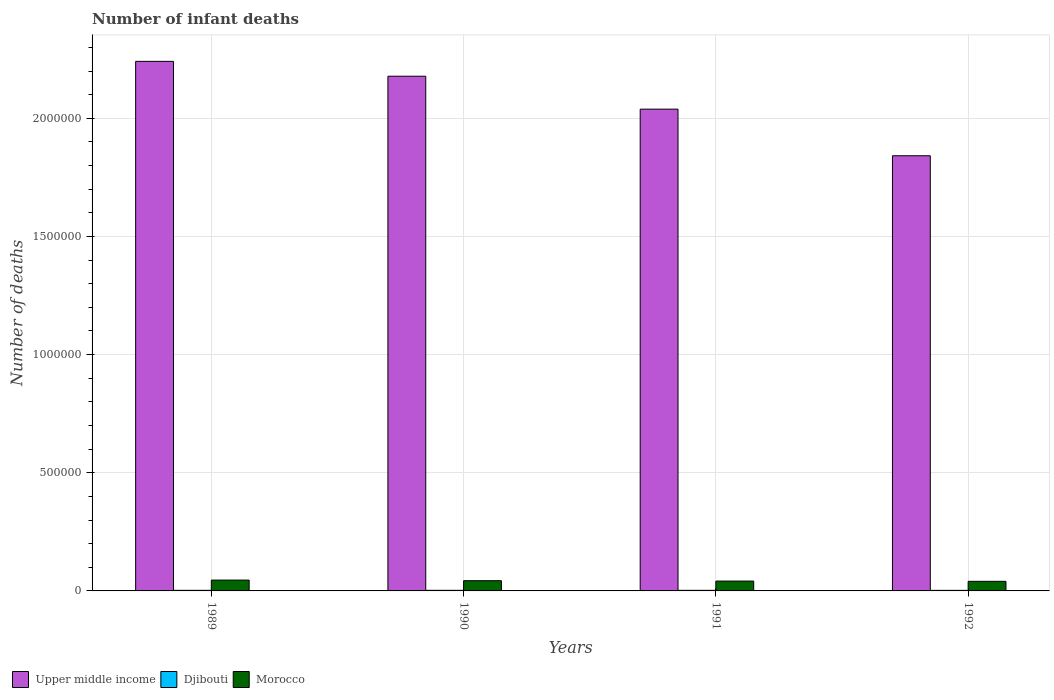Are the number of bars per tick equal to the number of legend labels?
Make the answer very short. Yes. What is the label of the 1st group of bars from the left?
Offer a terse response. 1989. What is the number of infant deaths in Morocco in 1990?
Give a very brief answer. 4.33e+04. Across all years, what is the maximum number of infant deaths in Djibouti?
Make the answer very short. 2531. Across all years, what is the minimum number of infant deaths in Upper middle income?
Make the answer very short. 1.84e+06. In which year was the number of infant deaths in Djibouti maximum?
Offer a terse response. 1990. In which year was the number of infant deaths in Upper middle income minimum?
Your answer should be very brief. 1992. What is the total number of infant deaths in Morocco in the graph?
Provide a short and direct response. 1.71e+05. What is the difference between the number of infant deaths in Djibouti in 1991 and that in 1992?
Provide a succinct answer. 133. What is the difference between the number of infant deaths in Morocco in 1991 and the number of infant deaths in Djibouti in 1990?
Offer a terse response. 3.91e+04. What is the average number of infant deaths in Morocco per year?
Make the answer very short. 4.29e+04. In the year 1990, what is the difference between the number of infant deaths in Djibouti and number of infant deaths in Upper middle income?
Your answer should be compact. -2.18e+06. In how many years, is the number of infant deaths in Morocco greater than 1800000?
Offer a terse response. 0. What is the ratio of the number of infant deaths in Upper middle income in 1990 to that in 1991?
Offer a terse response. 1.07. Is the difference between the number of infant deaths in Djibouti in 1989 and 1991 greater than the difference between the number of infant deaths in Upper middle income in 1989 and 1991?
Provide a succinct answer. No. What is the difference between the highest and the second highest number of infant deaths in Djibouti?
Provide a succinct answer. 23. What is the difference between the highest and the lowest number of infant deaths in Upper middle income?
Provide a short and direct response. 3.99e+05. Is the sum of the number of infant deaths in Upper middle income in 1989 and 1990 greater than the maximum number of infant deaths in Djibouti across all years?
Give a very brief answer. Yes. What does the 2nd bar from the left in 1992 represents?
Your response must be concise. Djibouti. What does the 3rd bar from the right in 1992 represents?
Your answer should be compact. Upper middle income. Is it the case that in every year, the sum of the number of infant deaths in Djibouti and number of infant deaths in Morocco is greater than the number of infant deaths in Upper middle income?
Provide a short and direct response. No. Are all the bars in the graph horizontal?
Offer a very short reply. No. How many years are there in the graph?
Provide a succinct answer. 4. Does the graph contain any zero values?
Your response must be concise. No. Does the graph contain grids?
Offer a terse response. Yes. Where does the legend appear in the graph?
Offer a terse response. Bottom left. How are the legend labels stacked?
Offer a terse response. Horizontal. What is the title of the graph?
Your response must be concise. Number of infant deaths. Does "Congo (Democratic)" appear as one of the legend labels in the graph?
Make the answer very short. No. What is the label or title of the Y-axis?
Ensure brevity in your answer.  Number of deaths. What is the Number of deaths of Upper middle income in 1989?
Your answer should be very brief. 2.24e+06. What is the Number of deaths in Djibouti in 1989?
Offer a very short reply. 2457. What is the Number of deaths in Morocco in 1989?
Offer a very short reply. 4.59e+04. What is the Number of deaths in Upper middle income in 1990?
Provide a succinct answer. 2.18e+06. What is the Number of deaths of Djibouti in 1990?
Provide a succinct answer. 2531. What is the Number of deaths of Morocco in 1990?
Keep it short and to the point. 4.33e+04. What is the Number of deaths in Upper middle income in 1991?
Offer a very short reply. 2.04e+06. What is the Number of deaths in Djibouti in 1991?
Ensure brevity in your answer.  2508. What is the Number of deaths of Morocco in 1991?
Your answer should be compact. 4.17e+04. What is the Number of deaths in Upper middle income in 1992?
Make the answer very short. 1.84e+06. What is the Number of deaths of Djibouti in 1992?
Your answer should be very brief. 2375. What is the Number of deaths of Morocco in 1992?
Your response must be concise. 4.06e+04. Across all years, what is the maximum Number of deaths of Upper middle income?
Provide a short and direct response. 2.24e+06. Across all years, what is the maximum Number of deaths of Djibouti?
Your answer should be very brief. 2531. Across all years, what is the maximum Number of deaths of Morocco?
Your answer should be compact. 4.59e+04. Across all years, what is the minimum Number of deaths of Upper middle income?
Your response must be concise. 1.84e+06. Across all years, what is the minimum Number of deaths in Djibouti?
Offer a terse response. 2375. Across all years, what is the minimum Number of deaths in Morocco?
Give a very brief answer. 4.06e+04. What is the total Number of deaths in Upper middle income in the graph?
Offer a very short reply. 8.30e+06. What is the total Number of deaths in Djibouti in the graph?
Provide a short and direct response. 9871. What is the total Number of deaths in Morocco in the graph?
Your answer should be compact. 1.71e+05. What is the difference between the Number of deaths in Upper middle income in 1989 and that in 1990?
Make the answer very short. 6.29e+04. What is the difference between the Number of deaths in Djibouti in 1989 and that in 1990?
Your answer should be compact. -74. What is the difference between the Number of deaths of Morocco in 1989 and that in 1990?
Offer a terse response. 2608. What is the difference between the Number of deaths of Upper middle income in 1989 and that in 1991?
Ensure brevity in your answer.  2.02e+05. What is the difference between the Number of deaths of Djibouti in 1989 and that in 1991?
Offer a very short reply. -51. What is the difference between the Number of deaths in Morocco in 1989 and that in 1991?
Provide a short and direct response. 4208. What is the difference between the Number of deaths in Upper middle income in 1989 and that in 1992?
Your answer should be very brief. 3.99e+05. What is the difference between the Number of deaths in Morocco in 1989 and that in 1992?
Your answer should be compact. 5280. What is the difference between the Number of deaths of Upper middle income in 1990 and that in 1991?
Make the answer very short. 1.39e+05. What is the difference between the Number of deaths of Djibouti in 1990 and that in 1991?
Provide a short and direct response. 23. What is the difference between the Number of deaths in Morocco in 1990 and that in 1991?
Make the answer very short. 1600. What is the difference between the Number of deaths of Upper middle income in 1990 and that in 1992?
Your answer should be compact. 3.37e+05. What is the difference between the Number of deaths in Djibouti in 1990 and that in 1992?
Give a very brief answer. 156. What is the difference between the Number of deaths of Morocco in 1990 and that in 1992?
Ensure brevity in your answer.  2672. What is the difference between the Number of deaths in Upper middle income in 1991 and that in 1992?
Ensure brevity in your answer.  1.97e+05. What is the difference between the Number of deaths in Djibouti in 1991 and that in 1992?
Offer a very short reply. 133. What is the difference between the Number of deaths in Morocco in 1991 and that in 1992?
Provide a short and direct response. 1072. What is the difference between the Number of deaths in Upper middle income in 1989 and the Number of deaths in Djibouti in 1990?
Provide a short and direct response. 2.24e+06. What is the difference between the Number of deaths in Upper middle income in 1989 and the Number of deaths in Morocco in 1990?
Offer a terse response. 2.20e+06. What is the difference between the Number of deaths in Djibouti in 1989 and the Number of deaths in Morocco in 1990?
Your answer should be compact. -4.08e+04. What is the difference between the Number of deaths in Upper middle income in 1989 and the Number of deaths in Djibouti in 1991?
Give a very brief answer. 2.24e+06. What is the difference between the Number of deaths in Upper middle income in 1989 and the Number of deaths in Morocco in 1991?
Make the answer very short. 2.20e+06. What is the difference between the Number of deaths of Djibouti in 1989 and the Number of deaths of Morocco in 1991?
Your answer should be very brief. -3.92e+04. What is the difference between the Number of deaths in Upper middle income in 1989 and the Number of deaths in Djibouti in 1992?
Your answer should be very brief. 2.24e+06. What is the difference between the Number of deaths in Upper middle income in 1989 and the Number of deaths in Morocco in 1992?
Give a very brief answer. 2.20e+06. What is the difference between the Number of deaths of Djibouti in 1989 and the Number of deaths of Morocco in 1992?
Make the answer very short. -3.81e+04. What is the difference between the Number of deaths of Upper middle income in 1990 and the Number of deaths of Djibouti in 1991?
Provide a short and direct response. 2.18e+06. What is the difference between the Number of deaths in Upper middle income in 1990 and the Number of deaths in Morocco in 1991?
Provide a succinct answer. 2.14e+06. What is the difference between the Number of deaths of Djibouti in 1990 and the Number of deaths of Morocco in 1991?
Ensure brevity in your answer.  -3.91e+04. What is the difference between the Number of deaths of Upper middle income in 1990 and the Number of deaths of Djibouti in 1992?
Provide a short and direct response. 2.18e+06. What is the difference between the Number of deaths in Upper middle income in 1990 and the Number of deaths in Morocco in 1992?
Your answer should be very brief. 2.14e+06. What is the difference between the Number of deaths in Djibouti in 1990 and the Number of deaths in Morocco in 1992?
Your response must be concise. -3.81e+04. What is the difference between the Number of deaths of Upper middle income in 1991 and the Number of deaths of Djibouti in 1992?
Give a very brief answer. 2.04e+06. What is the difference between the Number of deaths in Upper middle income in 1991 and the Number of deaths in Morocco in 1992?
Provide a short and direct response. 2.00e+06. What is the difference between the Number of deaths of Djibouti in 1991 and the Number of deaths of Morocco in 1992?
Provide a short and direct response. -3.81e+04. What is the average Number of deaths in Upper middle income per year?
Make the answer very short. 2.07e+06. What is the average Number of deaths of Djibouti per year?
Your answer should be compact. 2467.75. What is the average Number of deaths of Morocco per year?
Ensure brevity in your answer.  4.29e+04. In the year 1989, what is the difference between the Number of deaths in Upper middle income and Number of deaths in Djibouti?
Your answer should be very brief. 2.24e+06. In the year 1989, what is the difference between the Number of deaths in Upper middle income and Number of deaths in Morocco?
Your answer should be very brief. 2.20e+06. In the year 1989, what is the difference between the Number of deaths in Djibouti and Number of deaths in Morocco?
Provide a short and direct response. -4.34e+04. In the year 1990, what is the difference between the Number of deaths of Upper middle income and Number of deaths of Djibouti?
Offer a terse response. 2.18e+06. In the year 1990, what is the difference between the Number of deaths in Upper middle income and Number of deaths in Morocco?
Offer a very short reply. 2.13e+06. In the year 1990, what is the difference between the Number of deaths of Djibouti and Number of deaths of Morocco?
Ensure brevity in your answer.  -4.07e+04. In the year 1991, what is the difference between the Number of deaths of Upper middle income and Number of deaths of Djibouti?
Provide a short and direct response. 2.04e+06. In the year 1991, what is the difference between the Number of deaths in Upper middle income and Number of deaths in Morocco?
Give a very brief answer. 2.00e+06. In the year 1991, what is the difference between the Number of deaths of Djibouti and Number of deaths of Morocco?
Your answer should be very brief. -3.92e+04. In the year 1992, what is the difference between the Number of deaths of Upper middle income and Number of deaths of Djibouti?
Offer a very short reply. 1.84e+06. In the year 1992, what is the difference between the Number of deaths of Upper middle income and Number of deaths of Morocco?
Offer a very short reply. 1.80e+06. In the year 1992, what is the difference between the Number of deaths in Djibouti and Number of deaths in Morocco?
Provide a short and direct response. -3.82e+04. What is the ratio of the Number of deaths in Upper middle income in 1989 to that in 1990?
Your answer should be very brief. 1.03. What is the ratio of the Number of deaths of Djibouti in 1989 to that in 1990?
Ensure brevity in your answer.  0.97. What is the ratio of the Number of deaths in Morocco in 1989 to that in 1990?
Offer a very short reply. 1.06. What is the ratio of the Number of deaths of Upper middle income in 1989 to that in 1991?
Your answer should be compact. 1.1. What is the ratio of the Number of deaths in Djibouti in 1989 to that in 1991?
Provide a short and direct response. 0.98. What is the ratio of the Number of deaths of Morocco in 1989 to that in 1991?
Give a very brief answer. 1.1. What is the ratio of the Number of deaths in Upper middle income in 1989 to that in 1992?
Provide a short and direct response. 1.22. What is the ratio of the Number of deaths of Djibouti in 1989 to that in 1992?
Your response must be concise. 1.03. What is the ratio of the Number of deaths in Morocco in 1989 to that in 1992?
Your answer should be very brief. 1.13. What is the ratio of the Number of deaths in Upper middle income in 1990 to that in 1991?
Your answer should be compact. 1.07. What is the ratio of the Number of deaths in Djibouti in 1990 to that in 1991?
Provide a succinct answer. 1.01. What is the ratio of the Number of deaths of Morocco in 1990 to that in 1991?
Your response must be concise. 1.04. What is the ratio of the Number of deaths in Upper middle income in 1990 to that in 1992?
Your answer should be very brief. 1.18. What is the ratio of the Number of deaths in Djibouti in 1990 to that in 1992?
Your answer should be very brief. 1.07. What is the ratio of the Number of deaths in Morocco in 1990 to that in 1992?
Provide a short and direct response. 1.07. What is the ratio of the Number of deaths in Upper middle income in 1991 to that in 1992?
Offer a terse response. 1.11. What is the ratio of the Number of deaths of Djibouti in 1991 to that in 1992?
Give a very brief answer. 1.06. What is the ratio of the Number of deaths of Morocco in 1991 to that in 1992?
Offer a very short reply. 1.03. What is the difference between the highest and the second highest Number of deaths in Upper middle income?
Provide a succinct answer. 6.29e+04. What is the difference between the highest and the second highest Number of deaths of Morocco?
Provide a succinct answer. 2608. What is the difference between the highest and the lowest Number of deaths of Upper middle income?
Offer a very short reply. 3.99e+05. What is the difference between the highest and the lowest Number of deaths in Djibouti?
Ensure brevity in your answer.  156. What is the difference between the highest and the lowest Number of deaths of Morocco?
Offer a terse response. 5280. 